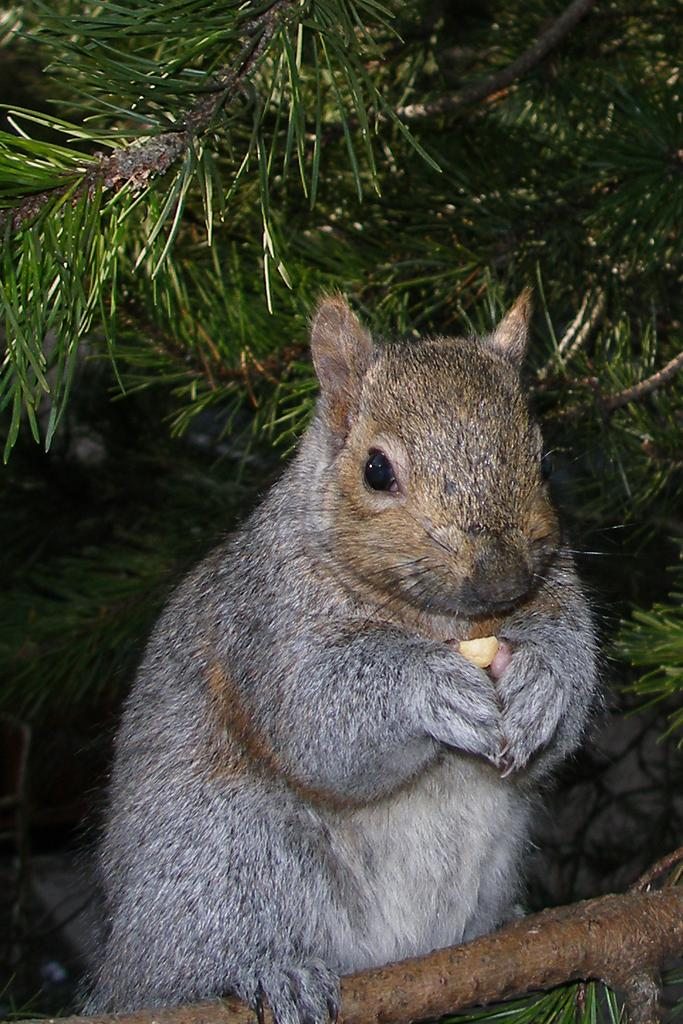What animal can be seen in the picture? There is a squirrel in the picture. What is the squirrel holding in its hands? The squirrel is holding something. What can be seen in the background of the picture? There is a tree in the background of the picture. What is the name of the person standing next to the squirrel in the picture? There is no person standing next to the squirrel in the picture; it only features the squirrel and the object it is holding. 